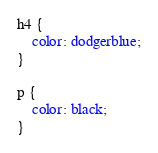<code> <loc_0><loc_0><loc_500><loc_500><_CSS_>h4 {
    color: dodgerblue;
}

p {
    color: black;
}</code> 